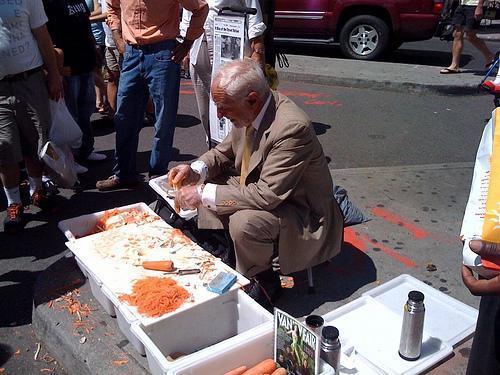How many people are there?
Give a very brief answer. 6. How many red umbrellas are there?
Give a very brief answer. 0. 